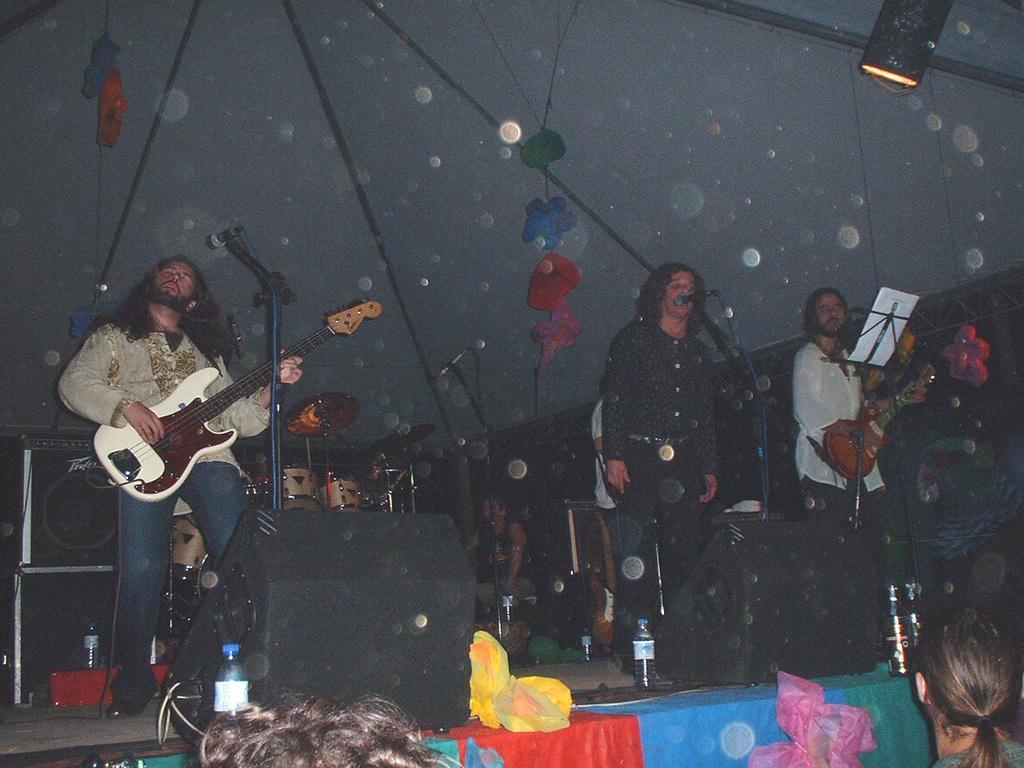Describe this image in one or two sentences. The picture is taken in a musical concert where a guy is playing guitar on the left side of the image with mic in front of him. A black shirt guy is singing in the center of the image. There are black boxes on the floor. In the background there is a white curtain and designed labels. There is also a lamp focusing on these musicians. 